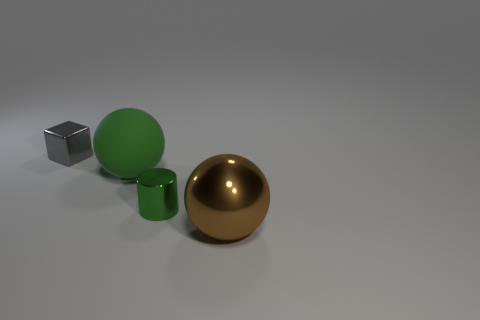Add 2 small purple balls. How many objects exist? 6 Subtract all cubes. How many objects are left? 3 Add 1 gray cubes. How many gray cubes are left? 2 Add 1 large brown spheres. How many large brown spheres exist? 2 Subtract 0 gray cylinders. How many objects are left? 4 Subtract all small gray things. Subtract all big green rubber things. How many objects are left? 2 